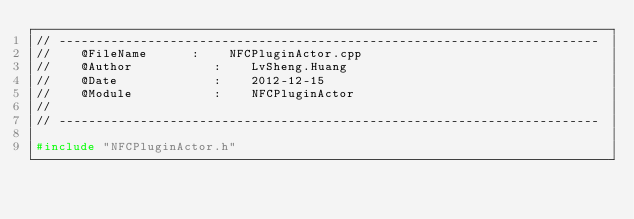Convert code to text. <code><loc_0><loc_0><loc_500><loc_500><_C++_>// -------------------------------------------------------------------------
//    @FileName      :    NFCPluginActor.cpp
//    @Author           :    LvSheng.Huang
//    @Date             :    2012-12-15
//    @Module           :    NFCPluginActor
//
// -------------------------------------------------------------------------

#include "NFCPluginActor.h"
</code> 